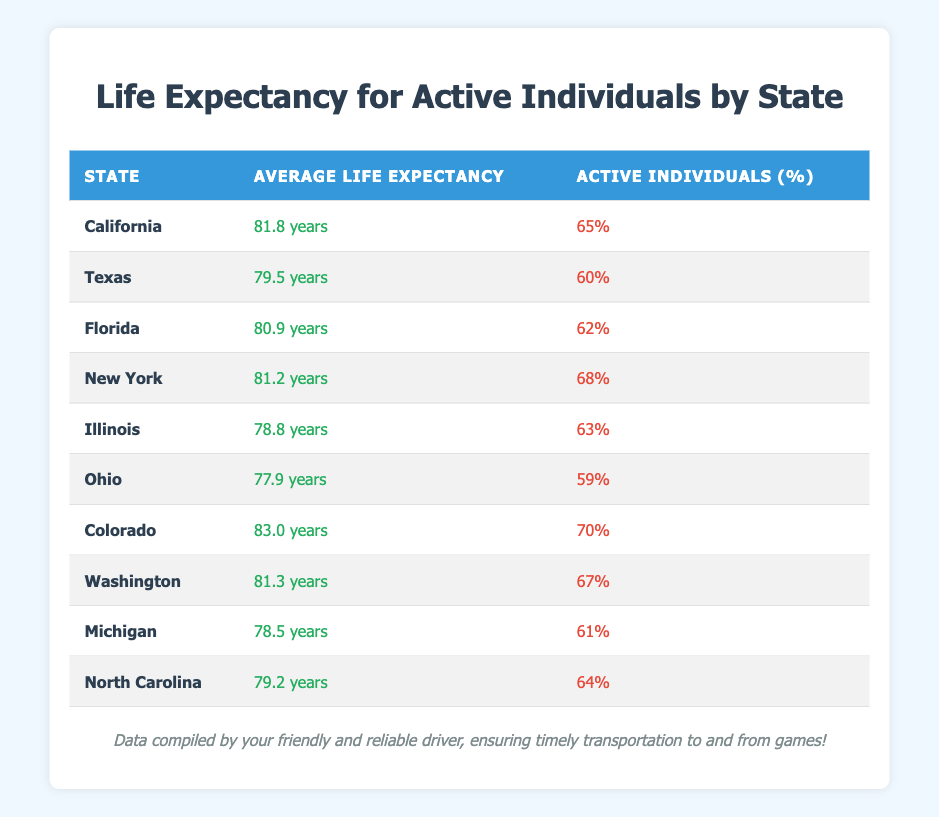What is the average life expectancy in California? The table lists California with an average life expectancy of 81.8 years. Therefore, the answer is directly found in the state's row.
Answer: 81.8 years Which state has the highest average life expectancy? By examining the 'Average Life Expectancy' column, Colorado is the only state with a life expectancy of 83.0 years, which is higher than all others in the table.
Answer: Colorado How many states have an active individuals percentage greater than 65%? The table shows California, New York, Colorado, and Washington with active individuals percentages of 65%, 68%, 70%, and 67%, respectively. This makes a total of four states.
Answer: 4 states What is the difference in average life expectancy between Ohio and Illinois? Ohio has an average life expectancy of 77.9 years and Illinois has 78.8 years. The difference is calculated as 78.8 - 77.9 = 0.9 years.
Answer: 0.9 years Is the average life expectancy in Florida higher than in Texas? Florida has an average life expectancy of 80.9 years, while Texas has 79.5 years. This means Florida's life expectancy is higher than Texas's.
Answer: Yes Which state has the lowest average life expectancy for active individuals? Illinois has the lowest average life expectancy of 78.8 years among the states listed in the table.
Answer: Illinois What is the average life expectancy of the states listed that have an active individuals percentage below 60%? The only state with an active individuals percentage below 60% is Ohio, with an average life expectancy of 77.9 years. Therefore, the average is just 77.9 years.
Answer: 77.9 years If we were to sum the average life expectancy of all the states, what would that total be? The average life expectancies are 81.8, 79.5, 80.9, 81.2, 78.8, 77.9, 83.0, 81.3, 78.5, and 79.2. Adding them together gives 81.8 + 79.5 + 80.9 + 81.2 + 78.8 + 77.9 + 83.0 + 81.3 + 78.5 + 79.2 =  1036.1 years.
Answer: 1036.1 years How many states have an active individuals percentage of 60% or higher? The states that meet this criterion are California, Florida, New York, Illinois, Colorado, Washington, and North Carolina, making it a total of six states.
Answer: 6 states 